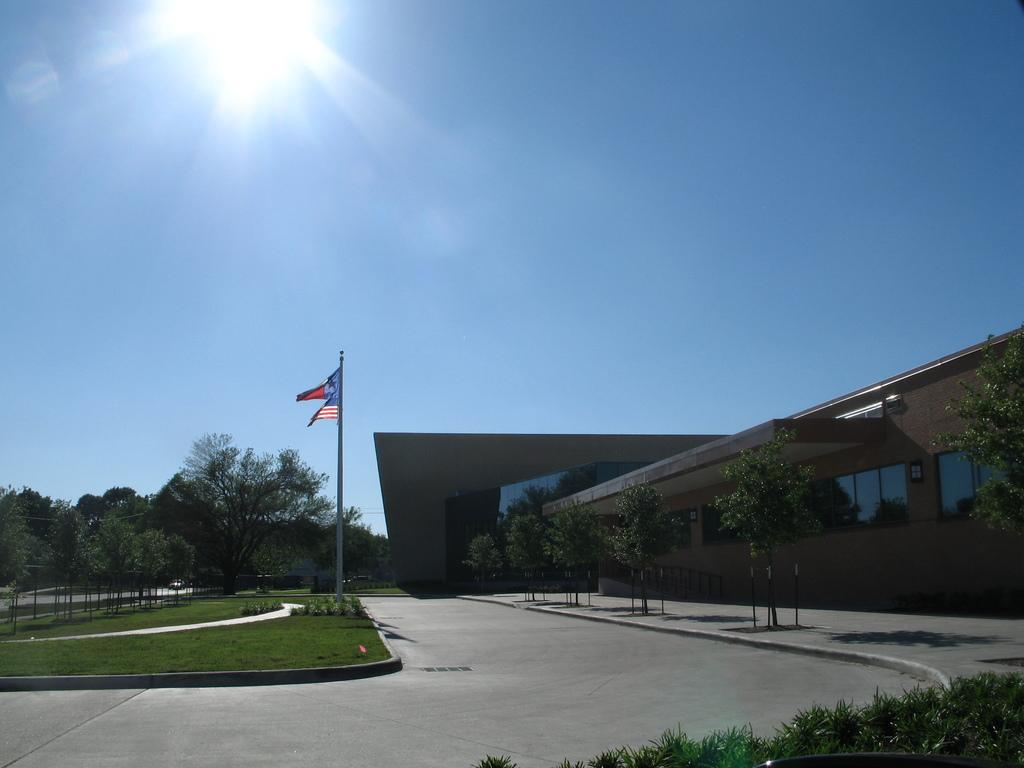What type of structure is visible in the image? There is a house in the image. What natural elements can be seen in the image? There are trees and plants in the image. What is attached to a pole in the image? There is a flag on a pole in the image. What type of wire is holding up the pigs in the image? There are no pigs present in the image, and therefore no wire holding them up. 